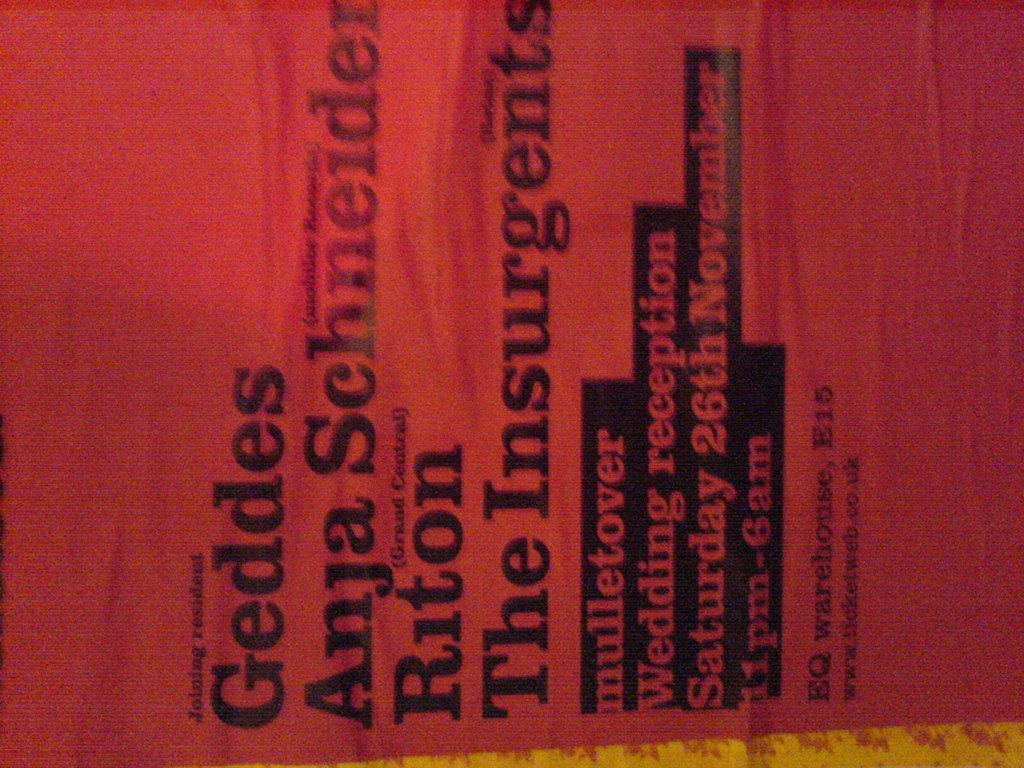<image>
Create a compact narrative representing the image presented. Red cover showing the word "Geddes" on the top. 